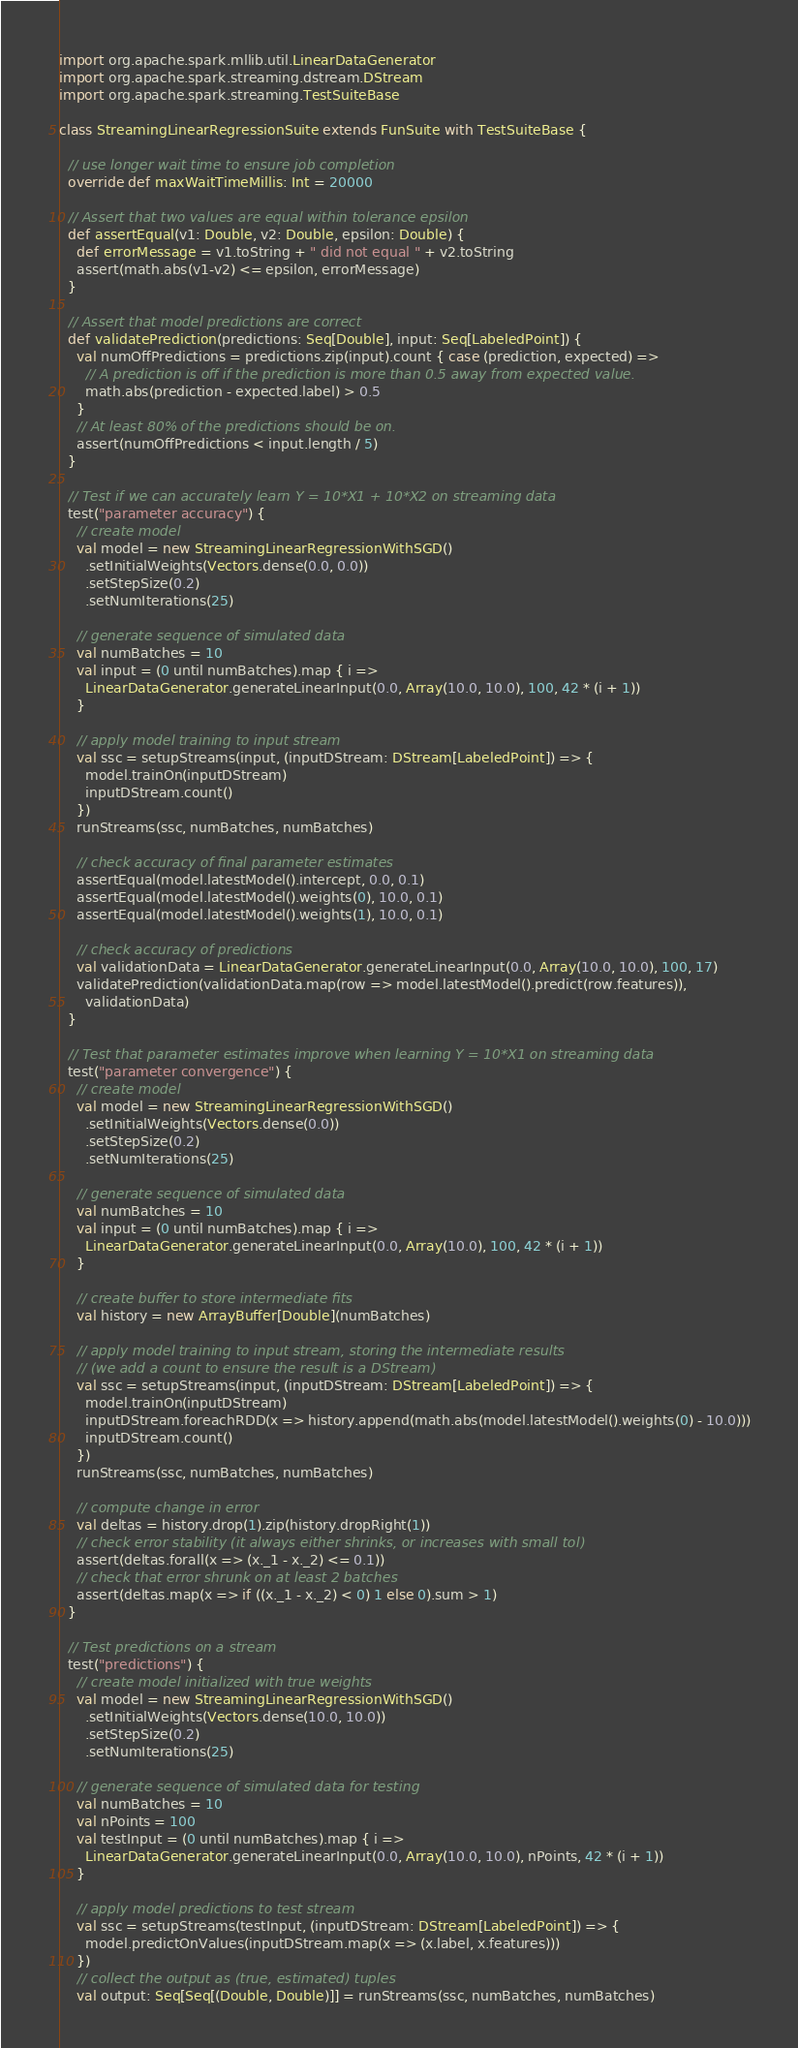<code> <loc_0><loc_0><loc_500><loc_500><_Scala_>import org.apache.spark.mllib.util.LinearDataGenerator
import org.apache.spark.streaming.dstream.DStream
import org.apache.spark.streaming.TestSuiteBase

class StreamingLinearRegressionSuite extends FunSuite with TestSuiteBase {

  // use longer wait time to ensure job completion
  override def maxWaitTimeMillis: Int = 20000

  // Assert that two values are equal within tolerance epsilon
  def assertEqual(v1: Double, v2: Double, epsilon: Double) {
    def errorMessage = v1.toString + " did not equal " + v2.toString
    assert(math.abs(v1-v2) <= epsilon, errorMessage)
  }

  // Assert that model predictions are correct
  def validatePrediction(predictions: Seq[Double], input: Seq[LabeledPoint]) {
    val numOffPredictions = predictions.zip(input).count { case (prediction, expected) =>
      // A prediction is off if the prediction is more than 0.5 away from expected value.
      math.abs(prediction - expected.label) > 0.5
    }
    // At least 80% of the predictions should be on.
    assert(numOffPredictions < input.length / 5)
  }

  // Test if we can accurately learn Y = 10*X1 + 10*X2 on streaming data
  test("parameter accuracy") {
    // create model
    val model = new StreamingLinearRegressionWithSGD()
      .setInitialWeights(Vectors.dense(0.0, 0.0))
      .setStepSize(0.2)
      .setNumIterations(25)

    // generate sequence of simulated data
    val numBatches = 10
    val input = (0 until numBatches).map { i =>
      LinearDataGenerator.generateLinearInput(0.0, Array(10.0, 10.0), 100, 42 * (i + 1))
    }

    // apply model training to input stream
    val ssc = setupStreams(input, (inputDStream: DStream[LabeledPoint]) => {
      model.trainOn(inputDStream)
      inputDStream.count()
    })
    runStreams(ssc, numBatches, numBatches)

    // check accuracy of final parameter estimates
    assertEqual(model.latestModel().intercept, 0.0, 0.1)
    assertEqual(model.latestModel().weights(0), 10.0, 0.1)
    assertEqual(model.latestModel().weights(1), 10.0, 0.1)

    // check accuracy of predictions
    val validationData = LinearDataGenerator.generateLinearInput(0.0, Array(10.0, 10.0), 100, 17)
    validatePrediction(validationData.map(row => model.latestModel().predict(row.features)),
      validationData)
  }

  // Test that parameter estimates improve when learning Y = 10*X1 on streaming data
  test("parameter convergence") {
    // create model
    val model = new StreamingLinearRegressionWithSGD()
      .setInitialWeights(Vectors.dense(0.0))
      .setStepSize(0.2)
      .setNumIterations(25)

    // generate sequence of simulated data
    val numBatches = 10
    val input = (0 until numBatches).map { i =>
      LinearDataGenerator.generateLinearInput(0.0, Array(10.0), 100, 42 * (i + 1))
    }

    // create buffer to store intermediate fits
    val history = new ArrayBuffer[Double](numBatches)

    // apply model training to input stream, storing the intermediate results
    // (we add a count to ensure the result is a DStream)
    val ssc = setupStreams(input, (inputDStream: DStream[LabeledPoint]) => {
      model.trainOn(inputDStream)
      inputDStream.foreachRDD(x => history.append(math.abs(model.latestModel().weights(0) - 10.0)))
      inputDStream.count()
    })
    runStreams(ssc, numBatches, numBatches)

    // compute change in error
    val deltas = history.drop(1).zip(history.dropRight(1))
    // check error stability (it always either shrinks, or increases with small tol)
    assert(deltas.forall(x => (x._1 - x._2) <= 0.1))
    // check that error shrunk on at least 2 batches
    assert(deltas.map(x => if ((x._1 - x._2) < 0) 1 else 0).sum > 1)
  }

  // Test predictions on a stream
  test("predictions") {
    // create model initialized with true weights
    val model = new StreamingLinearRegressionWithSGD()
      .setInitialWeights(Vectors.dense(10.0, 10.0))
      .setStepSize(0.2)
      .setNumIterations(25)

    // generate sequence of simulated data for testing
    val numBatches = 10
    val nPoints = 100
    val testInput = (0 until numBatches).map { i =>
      LinearDataGenerator.generateLinearInput(0.0, Array(10.0, 10.0), nPoints, 42 * (i + 1))
    }

    // apply model predictions to test stream
    val ssc = setupStreams(testInput, (inputDStream: DStream[LabeledPoint]) => {
      model.predictOnValues(inputDStream.map(x => (x.label, x.features)))
    })
    // collect the output as (true, estimated) tuples
    val output: Seq[Seq[(Double, Double)]] = runStreams(ssc, numBatches, numBatches)
</code> 